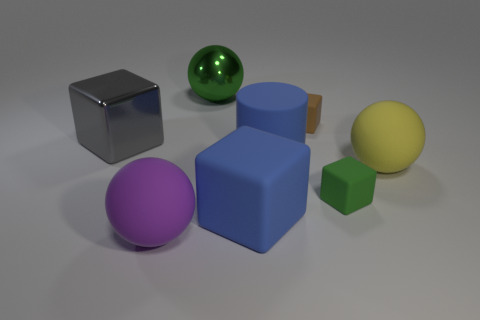Subtract all shiny balls. How many balls are left? 2 Add 2 tiny green rubber things. How many objects exist? 10 Subtract all purple balls. How many balls are left? 2 Subtract all spheres. How many objects are left? 5 Add 3 yellow matte things. How many yellow matte things exist? 4 Subtract 0 gray cylinders. How many objects are left? 8 Subtract 3 cubes. How many cubes are left? 1 Subtract all brown balls. Subtract all cyan cubes. How many balls are left? 3 Subtract all matte cubes. Subtract all gray metallic things. How many objects are left? 4 Add 5 green shiny spheres. How many green shiny spheres are left? 6 